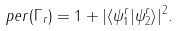Convert formula to latex. <formula><loc_0><loc_0><loc_500><loc_500>p e r ( { \Gamma } _ { r } ) = 1 + | { \langle } { \psi } _ { 1 } ^ { r } | { \psi } _ { 2 } ^ { r } { \rangle } | ^ { 2 } .</formula> 